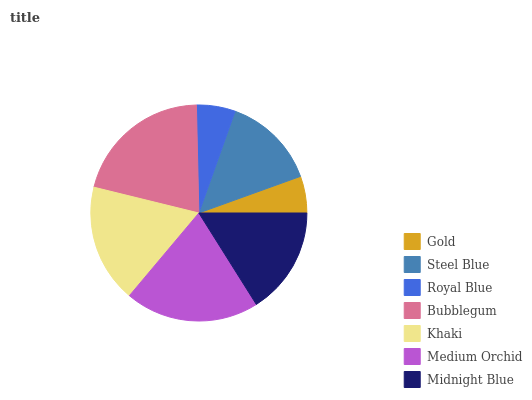Is Gold the minimum?
Answer yes or no. Yes. Is Bubblegum the maximum?
Answer yes or no. Yes. Is Steel Blue the minimum?
Answer yes or no. No. Is Steel Blue the maximum?
Answer yes or no. No. Is Steel Blue greater than Gold?
Answer yes or no. Yes. Is Gold less than Steel Blue?
Answer yes or no. Yes. Is Gold greater than Steel Blue?
Answer yes or no. No. Is Steel Blue less than Gold?
Answer yes or no. No. Is Midnight Blue the high median?
Answer yes or no. Yes. Is Midnight Blue the low median?
Answer yes or no. Yes. Is Medium Orchid the high median?
Answer yes or no. No. Is Royal Blue the low median?
Answer yes or no. No. 